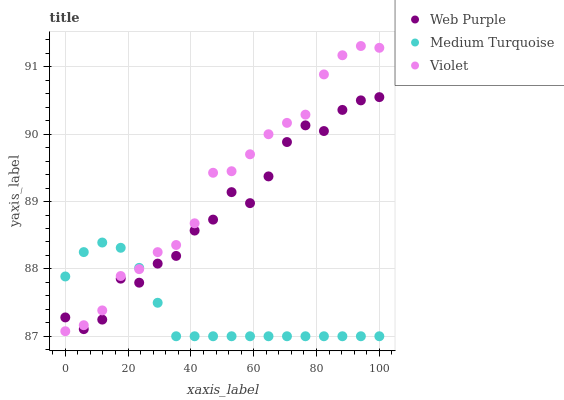Does Medium Turquoise have the minimum area under the curve?
Answer yes or no. Yes. Does Violet have the maximum area under the curve?
Answer yes or no. Yes. Does Violet have the minimum area under the curve?
Answer yes or no. No. Does Medium Turquoise have the maximum area under the curve?
Answer yes or no. No. Is Medium Turquoise the smoothest?
Answer yes or no. Yes. Is Web Purple the roughest?
Answer yes or no. Yes. Is Violet the smoothest?
Answer yes or no. No. Is Violet the roughest?
Answer yes or no. No. Does Medium Turquoise have the lowest value?
Answer yes or no. Yes. Does Violet have the lowest value?
Answer yes or no. No. Does Violet have the highest value?
Answer yes or no. Yes. Does Medium Turquoise have the highest value?
Answer yes or no. No. Does Violet intersect Medium Turquoise?
Answer yes or no. Yes. Is Violet less than Medium Turquoise?
Answer yes or no. No. Is Violet greater than Medium Turquoise?
Answer yes or no. No. 